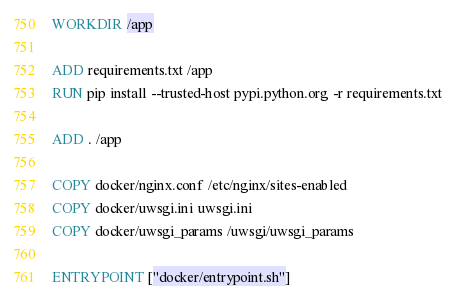Convert code to text. <code><loc_0><loc_0><loc_500><loc_500><_Dockerfile_>
WORKDIR /app

ADD requirements.txt /app
RUN pip install --trusted-host pypi.python.org -r requirements.txt

ADD . /app

COPY docker/nginx.conf /etc/nginx/sites-enabled
COPY docker/uwsgi.ini uwsgi.ini
COPY docker/uwsgi_params /uwsgi/uwsgi_params

ENTRYPOINT ["docker/entrypoint.sh"]</code> 